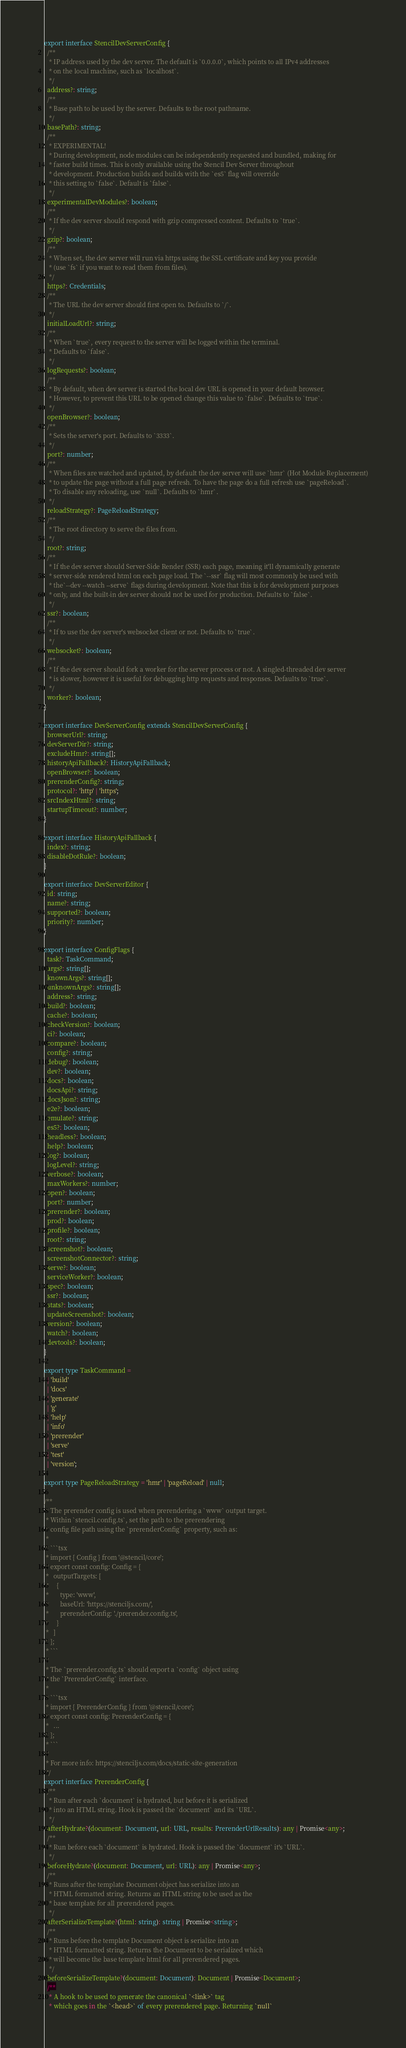<code> <loc_0><loc_0><loc_500><loc_500><_TypeScript_>export interface StencilDevServerConfig {
  /**
   * IP address used by the dev server. The default is `0.0.0.0`, which points to all IPv4 addresses
   * on the local machine, such as `localhost`.
   */
  address?: string;
  /**
   * Base path to be used by the server. Defaults to the root pathname.
   */
  basePath?: string;
  /**
   * EXPERIMENTAL!
   * During development, node modules can be independently requested and bundled, making for
   * faster build times. This is only available using the Stencil Dev Server throughout
   * development. Production builds and builds with the `es5` flag will override
   * this setting to `false`. Default is `false`.
   */
  experimentalDevModules?: boolean;
  /**
   * If the dev server should respond with gzip compressed content. Defaults to `true`.
   */
  gzip?: boolean;
  /**
   * When set, the dev server will run via https using the SSL certificate and key you provide
   * (use `fs` if you want to read them from files).
   */
  https?: Credentials;
  /**
   * The URL the dev server should first open to. Defaults to `/`.
   */
  initialLoadUrl?: string;
  /**
   * When `true`, every request to the server will be logged within the terminal.
   * Defaults to `false`.
   */
  logRequests?: boolean;
  /**
   * By default, when dev server is started the local dev URL is opened in your default browser.
   * However, to prevent this URL to be opened change this value to `false`. Defaults to `true`.
   */
  openBrowser?: boolean;
  /**
   * Sets the server's port. Defaults to `3333`.
   */
  port?: number;
  /**
   * When files are watched and updated, by default the dev server will use `hmr` (Hot Module Replacement)
   * to update the page without a full page refresh. To have the page do a full refresh use `pageReload`.
   * To disable any reloading, use `null`. Defaults to `hmr`.
   */
  reloadStrategy?: PageReloadStrategy;
  /**
   * The root directory to serve the files from.
   */
  root?: string;
  /**
   * If the dev server should Server-Side Render (SSR) each page, meaning it'll dynamically generate
   * server-side rendered html on each page load. The `--ssr` flag will most commonly be used with
   * the`--dev --watch --serve` flags during development. Note that this is for development purposes
   * only, and the built-in dev server should not be used for production. Defaults to `false`.
   */
  ssr?: boolean;
  /**
   * If to use the dev server's websocket client or not. Defaults to `true`.
   */
  websocket?: boolean;
  /**
   * If the dev server should fork a worker for the server process or not. A singled-threaded dev server
   * is slower, however it is useful for debugging http requests and responses. Defaults to `true`.
   */
  worker?: boolean;
}

export interface DevServerConfig extends StencilDevServerConfig {
  browserUrl?: string;
  devServerDir?: string;
  excludeHmr?: string[];
  historyApiFallback?: HistoryApiFallback;
  openBrowser?: boolean;
  prerenderConfig?: string;
  protocol?: 'http' | 'https';
  srcIndexHtml?: string;
  startupTimeout?: number;
}

export interface HistoryApiFallback {
  index?: string;
  disableDotRule?: boolean;
}

export interface DevServerEditor {
  id: string;
  name?: string;
  supported?: boolean;
  priority?: number;
}

export interface ConfigFlags {
  task?: TaskCommand;
  args?: string[];
  knownArgs?: string[];
  unknownArgs?: string[];
  address?: string;
  build?: boolean;
  cache?: boolean;
  checkVersion?: boolean;
  ci?: boolean;
  compare?: boolean;
  config?: string;
  debug?: boolean;
  dev?: boolean;
  docs?: boolean;
  docsApi?: string;
  docsJson?: string;
  e2e?: boolean;
  emulate?: string;
  es5?: boolean;
  headless?: boolean;
  help?: boolean;
  log?: boolean;
  logLevel?: string;
  verbose?: boolean;
  maxWorkers?: number;
  open?: boolean;
  port?: number;
  prerender?: boolean;
  prod?: boolean;
  profile?: boolean;
  root?: string;
  screenshot?: boolean;
  screenshotConnector?: string;
  serve?: boolean;
  serviceWorker?: boolean;
  spec?: boolean;
  ssr?: boolean;
  stats?: boolean;
  updateScreenshot?: boolean;
  version?: boolean;
  watch?: boolean;
  devtools?: boolean;
}

export type TaskCommand =
  | 'build'
  | 'docs'
  | 'generate'
  | 'g'
  | 'help'
  | 'info'
  | 'prerender'
  | 'serve'
  | 'test'
  | 'version';

export type PageReloadStrategy = 'hmr' | 'pageReload' | null;

/**
 * The prerender config is used when prerendering a `www` output target.
 * Within `stencil.config.ts`, set the path to the prerendering
 * config file path using the `prerenderConfig` property, such as:
 *
 * ```tsx
 * import { Config } from '@stencil/core';
 * export const config: Config = {
 *   outputTargets: [
 *     {
 *       type: 'www',
 *       baseUrl: 'https://stenciljs.com/',
 *       prerenderConfig: './prerender.config.ts',
 *     }
 *   ]
 * };
 * ```
 *
 * The `prerender.config.ts` should export a `config` object using
 * the `PrerenderConfig` interface.
 *
 * ```tsx
 * import { PrerenderConfig } from '@stencil/core';
 * export const config: PrerenderConfig = {
 *   ...
 * };
 * ```
 *
 * For more info: https://stenciljs.com/docs/static-site-generation
 */
export interface PrerenderConfig {
  /**
   * Run after each `document` is hydrated, but before it is serialized
   * into an HTML string. Hook is passed the `document` and its `URL`.
   */
  afterHydrate?(document: Document, url: URL, results: PrerenderUrlResults): any | Promise<any>;
  /**
   * Run before each `document` is hydrated. Hook is passed the `document` it's `URL`.
   */
  beforeHydrate?(document: Document, url: URL): any | Promise<any>;
  /**
   * Runs after the template Document object has serialize into an
   * HTML formatted string. Returns an HTML string to be used as the
   * base template for all prerendered pages.
   */
  afterSerializeTemplate?(html: string): string | Promise<string>;
  /**
   * Runs before the template Document object is serialize into an
   * HTML formatted string. Returns the Document to be serialized which
   * will become the base template html for all prerendered pages.
   */
  beforeSerializeTemplate?(document: Document): Document | Promise<Document>;
  /**
   * A hook to be used to generate the canonical `<link>` tag
   * which goes in the `<head>` of every prerendered page. Returning `null`</code> 